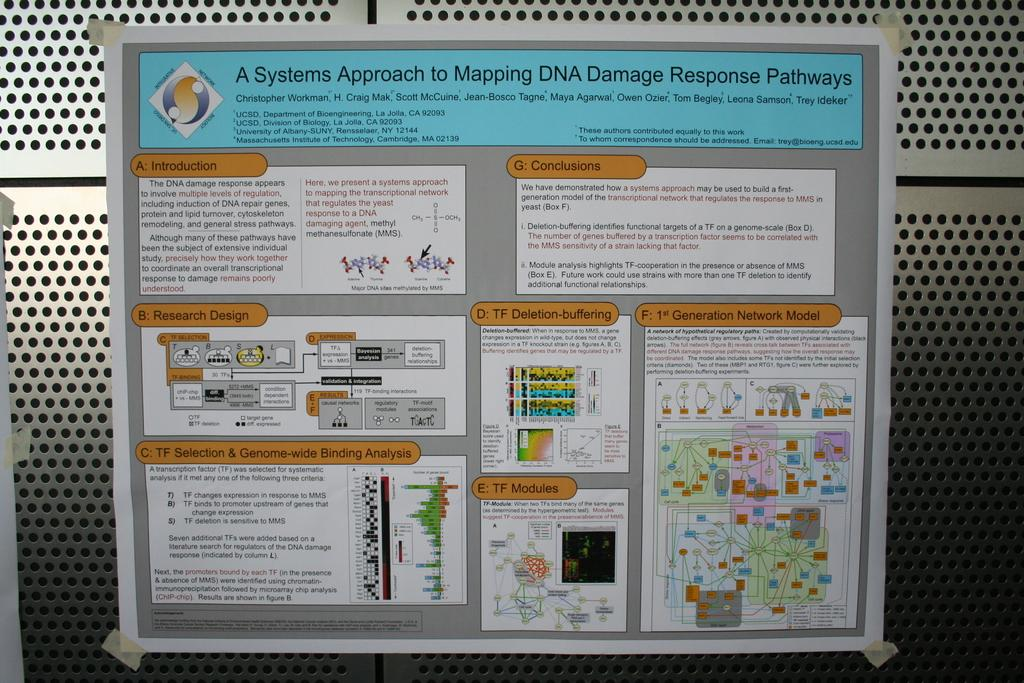What material is present in the background of the image? There is a metal sheet in the background of the image. What is attached to the metal sheet? There is a paper pasted to the metal sheet. What can be read on the paper? There is text visible on the paper. Can you see a duck swimming in the waves in the image? There is no duck or waves present in the image; it features a metal sheet with a paper pasted to it. 